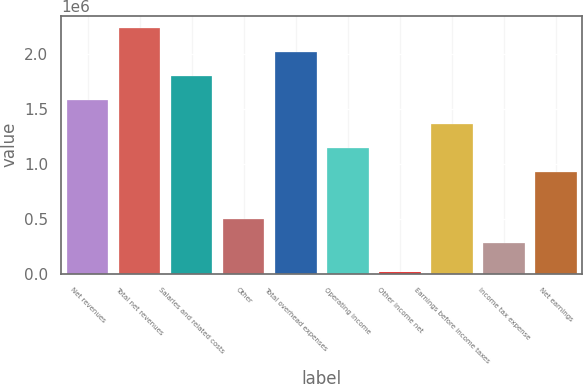Convert chart. <chart><loc_0><loc_0><loc_500><loc_500><bar_chart><fcel>Net revenues<fcel>Total net revenues<fcel>Salaries and related costs<fcel>Other<fcel>Total overhead expenses<fcel>Operating income<fcel>Other income net<fcel>Earnings before income taxes<fcel>Income tax expense<fcel>Net earnings<nl><fcel>1.58074e+06<fcel>2.23251e+06<fcel>1.79799e+06<fcel>494449<fcel>2.01525e+06<fcel>1.14622e+06<fcel>15205<fcel>1.36348e+06<fcel>277192<fcel>928964<nl></chart> 